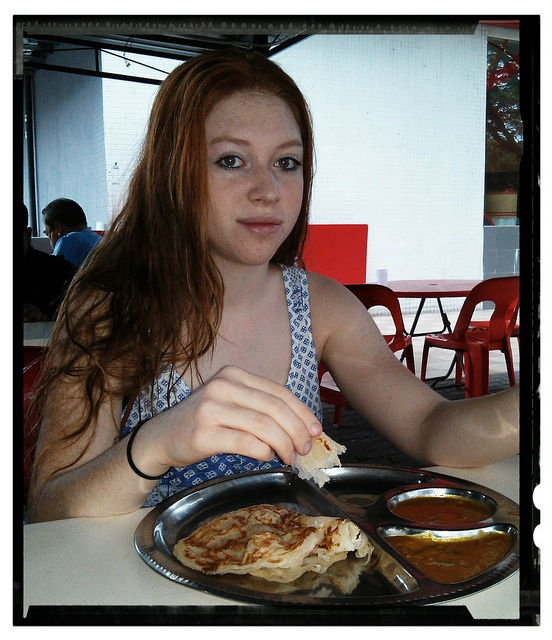Describe the objects in this image and their specific colors. I can see people in white, black, gray, and maroon tones, dining table in white, black, darkgray, maroon, and olive tones, chair in white, maroon, black, lightgray, and brown tones, chair in white, brown, black, maroon, and lightgray tones, and dining table in white, lightgray, darkgray, and black tones in this image. 